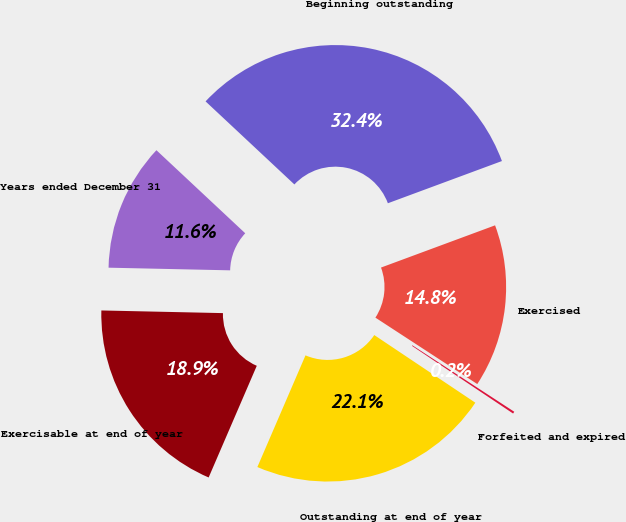<chart> <loc_0><loc_0><loc_500><loc_500><pie_chart><fcel>Years ended December 31<fcel>Beginning outstanding<fcel>Exercised<fcel>Forfeited and expired<fcel>Outstanding at end of year<fcel>Exercisable at end of year<nl><fcel>11.62%<fcel>32.39%<fcel>14.84%<fcel>0.19%<fcel>22.09%<fcel>18.87%<nl></chart> 